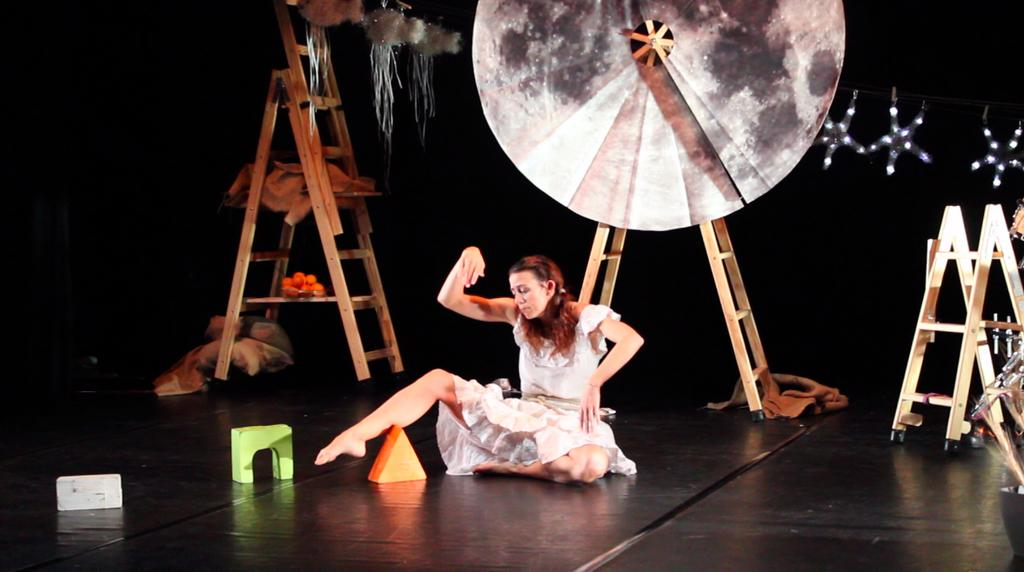Who is the main subject in the image? There is a woman in the image. What is the woman doing in the image? The woman is dancing. What color is the floor in the image? The floor is black. What other objects can be seen in the image besides the woman? There are objects, ladders, and decoration items in the image. How would you describe the background of the image? The background of the image has a dark view. Can you see any fog in the image? There is no fog present in the image. What type of fork is being used by the woman in the image? There is no fork visible in the image, as the woman is dancing and not using any utensils. 